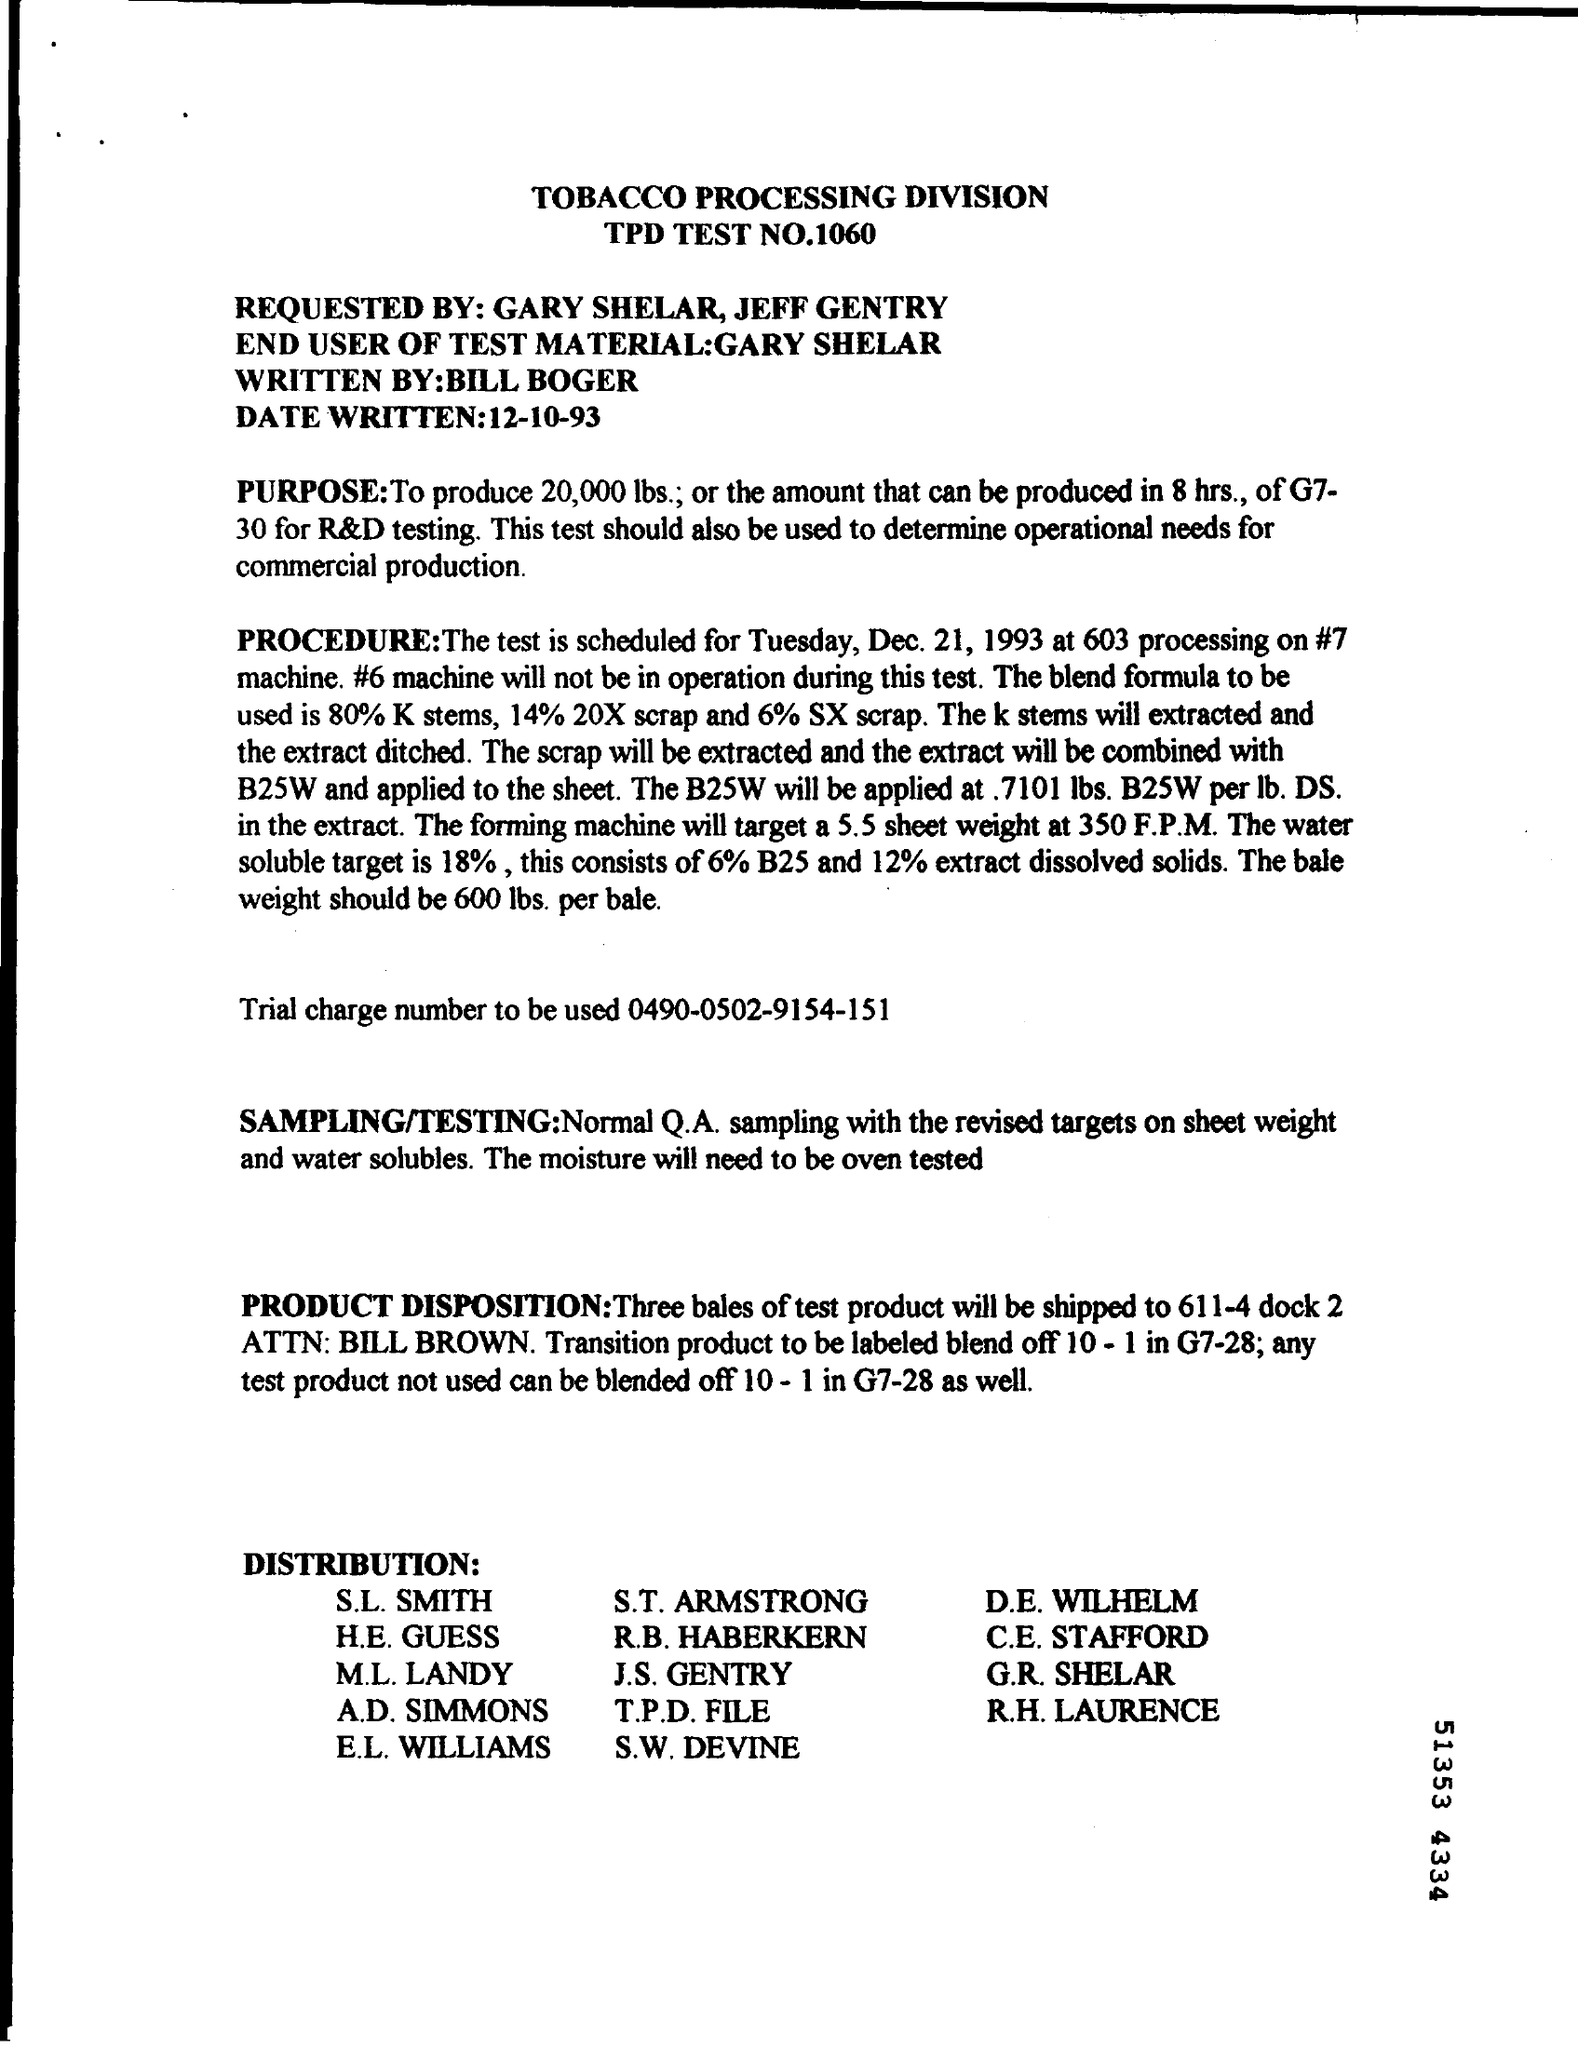Outline some significant characteristics in this image. The TPD test number is 1060. The Trial Charge Number is 0490-0502-9154-151. 